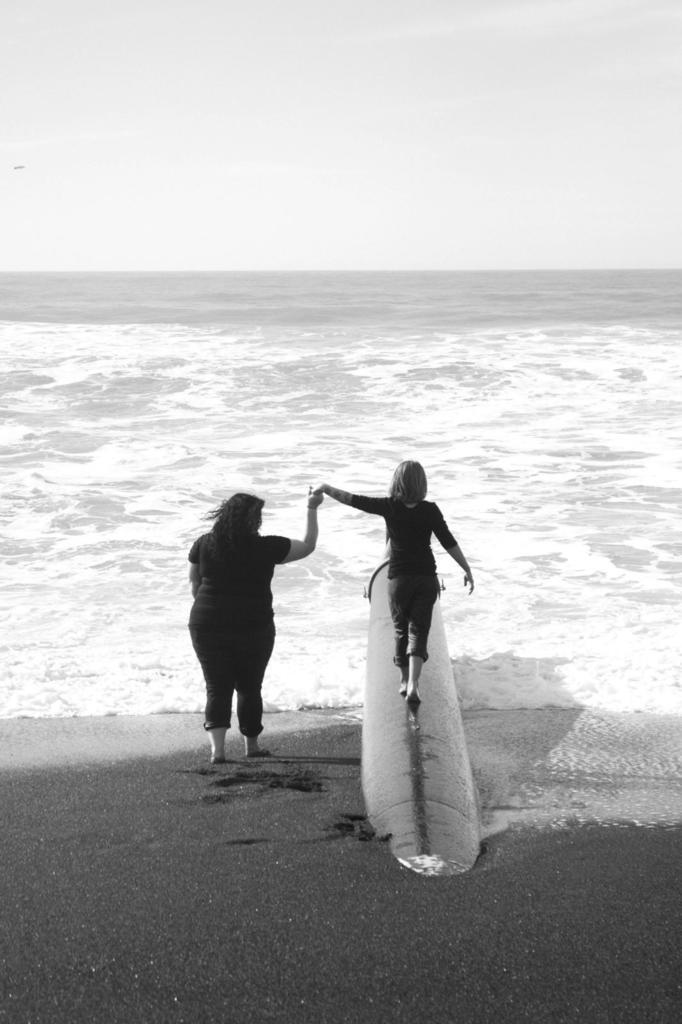Who are the people in the image? There is a woman and a girl in the image. What is the girl doing in the image? The girl is standing on an object in the image. What can be seen in the background of the image? Water and the sky are visible in the background of the image. What is the color scheme of the image? The image is black and white in color. Where is the crib located in the image? There is no crib present in the image. What type of church can be seen in the background of the image? There is no church visible in the background of the image. 